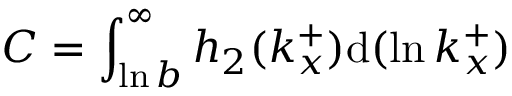<formula> <loc_0><loc_0><loc_500><loc_500>C = \int _ { \ln b } ^ { \infty } h _ { 2 } ( k _ { x } ^ { + } ) d ( \ln k _ { x } ^ { + } )</formula> 